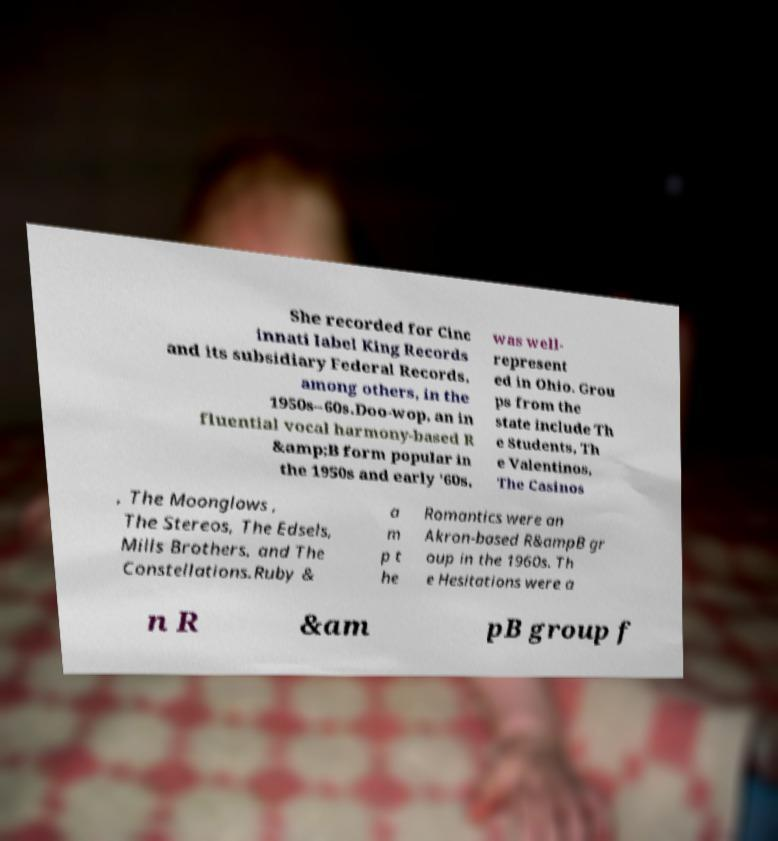Please identify and transcribe the text found in this image. She recorded for Cinc innati label King Records and its subsidiary Federal Records, among others, in the 1950s–60s.Doo-wop, an in fluential vocal harmony-based R &amp;B form popular in the 1950s and early '60s, was well- represent ed in Ohio. Grou ps from the state include Th e Students, Th e Valentinos, The Casinos , The Moonglows , The Stereos, The Edsels, Mills Brothers, and The Constellations.Ruby & a m p t he Romantics were an Akron-based R&ampB gr oup in the 1960s. Th e Hesitations were a n R &am pB group f 